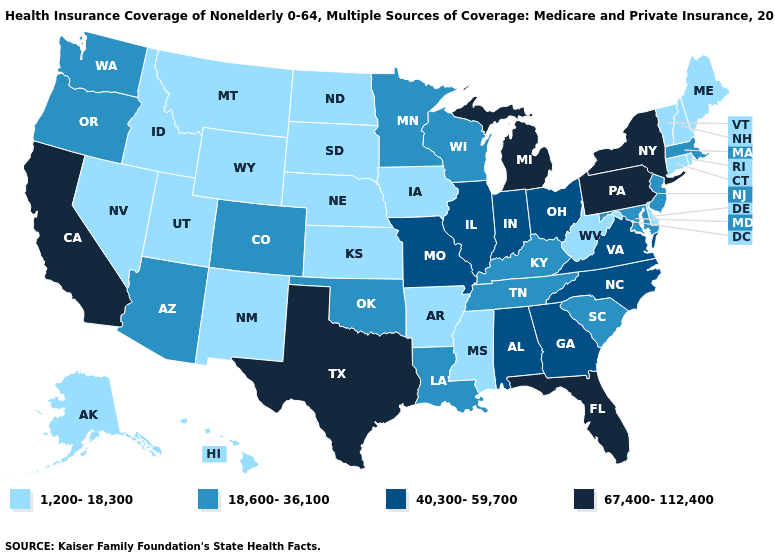Does Delaware have the highest value in the South?
Give a very brief answer. No. What is the lowest value in the USA?
Write a very short answer. 1,200-18,300. What is the value of Georgia?
Concise answer only. 40,300-59,700. What is the value of Alabama?
Answer briefly. 40,300-59,700. Name the states that have a value in the range 67,400-112,400?
Write a very short answer. California, Florida, Michigan, New York, Pennsylvania, Texas. What is the value of Iowa?
Write a very short answer. 1,200-18,300. Does Connecticut have a lower value than West Virginia?
Be succinct. No. Name the states that have a value in the range 1,200-18,300?
Quick response, please. Alaska, Arkansas, Connecticut, Delaware, Hawaii, Idaho, Iowa, Kansas, Maine, Mississippi, Montana, Nebraska, Nevada, New Hampshire, New Mexico, North Dakota, Rhode Island, South Dakota, Utah, Vermont, West Virginia, Wyoming. Which states have the lowest value in the South?
Quick response, please. Arkansas, Delaware, Mississippi, West Virginia. How many symbols are there in the legend?
Write a very short answer. 4. Does Delaware have the lowest value in the USA?
Keep it brief. Yes. Does Arizona have the lowest value in the USA?
Give a very brief answer. No. Among the states that border Maine , which have the lowest value?
Give a very brief answer. New Hampshire. What is the value of Alaska?
Concise answer only. 1,200-18,300. 